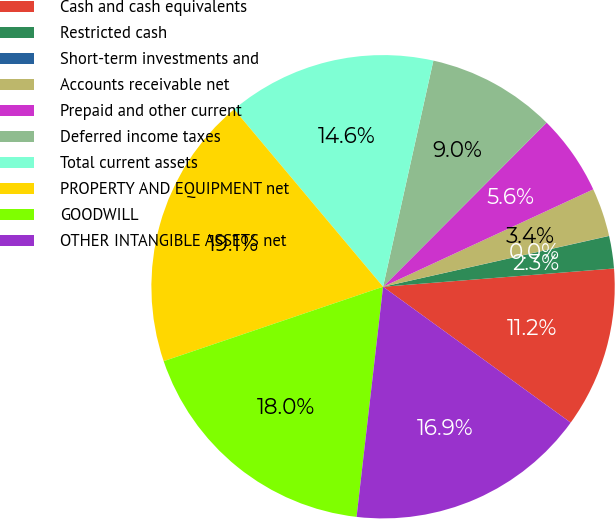<chart> <loc_0><loc_0><loc_500><loc_500><pie_chart><fcel>Cash and cash equivalents<fcel>Restricted cash<fcel>Short-term investments and<fcel>Accounts receivable net<fcel>Prepaid and other current<fcel>Deferred income taxes<fcel>Total current assets<fcel>PROPERTY AND EQUIPMENT net<fcel>GOODWILL<fcel>OTHER INTANGIBLE ASSETS net<nl><fcel>11.23%<fcel>2.26%<fcel>0.01%<fcel>3.38%<fcel>5.62%<fcel>8.99%<fcel>14.6%<fcel>19.09%<fcel>17.97%<fcel>16.85%<nl></chart> 